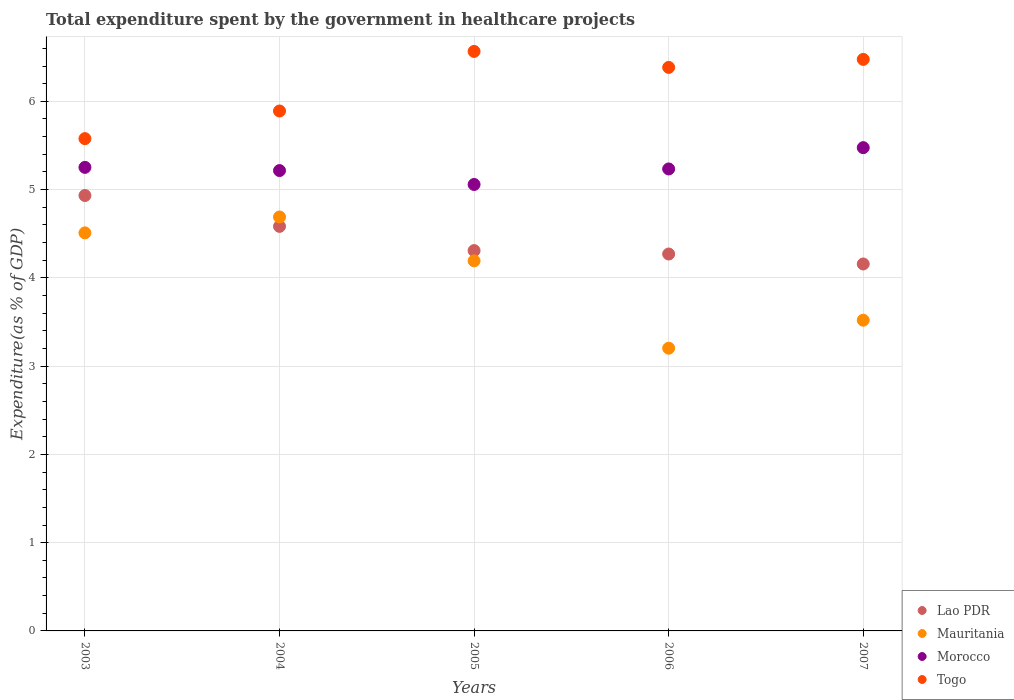Is the number of dotlines equal to the number of legend labels?
Keep it short and to the point. Yes. What is the total expenditure spent by the government in healthcare projects in Togo in 2005?
Offer a very short reply. 6.57. Across all years, what is the maximum total expenditure spent by the government in healthcare projects in Lao PDR?
Your answer should be compact. 4.93. Across all years, what is the minimum total expenditure spent by the government in healthcare projects in Morocco?
Ensure brevity in your answer.  5.06. In which year was the total expenditure spent by the government in healthcare projects in Lao PDR maximum?
Provide a succinct answer. 2003. What is the total total expenditure spent by the government in healthcare projects in Morocco in the graph?
Your answer should be compact. 26.23. What is the difference between the total expenditure spent by the government in healthcare projects in Togo in 2005 and that in 2006?
Ensure brevity in your answer.  0.18. What is the difference between the total expenditure spent by the government in healthcare projects in Morocco in 2003 and the total expenditure spent by the government in healthcare projects in Mauritania in 2005?
Ensure brevity in your answer.  1.06. What is the average total expenditure spent by the government in healthcare projects in Lao PDR per year?
Offer a very short reply. 4.45. In the year 2005, what is the difference between the total expenditure spent by the government in healthcare projects in Morocco and total expenditure spent by the government in healthcare projects in Lao PDR?
Provide a short and direct response. 0.75. What is the ratio of the total expenditure spent by the government in healthcare projects in Mauritania in 2003 to that in 2004?
Your answer should be compact. 0.96. Is the total expenditure spent by the government in healthcare projects in Morocco in 2004 less than that in 2006?
Your response must be concise. Yes. What is the difference between the highest and the second highest total expenditure spent by the government in healthcare projects in Mauritania?
Offer a very short reply. 0.18. What is the difference between the highest and the lowest total expenditure spent by the government in healthcare projects in Togo?
Ensure brevity in your answer.  0.99. Does the total expenditure spent by the government in healthcare projects in Togo monotonically increase over the years?
Offer a terse response. No. Is the total expenditure spent by the government in healthcare projects in Togo strictly less than the total expenditure spent by the government in healthcare projects in Mauritania over the years?
Give a very brief answer. No. How many years are there in the graph?
Your response must be concise. 5. What is the difference between two consecutive major ticks on the Y-axis?
Provide a succinct answer. 1. Are the values on the major ticks of Y-axis written in scientific E-notation?
Your answer should be very brief. No. Does the graph contain any zero values?
Your answer should be compact. No. Does the graph contain grids?
Your answer should be compact. Yes. How many legend labels are there?
Keep it short and to the point. 4. How are the legend labels stacked?
Provide a succinct answer. Vertical. What is the title of the graph?
Provide a short and direct response. Total expenditure spent by the government in healthcare projects. What is the label or title of the Y-axis?
Offer a very short reply. Expenditure(as % of GDP). What is the Expenditure(as % of GDP) of Lao PDR in 2003?
Ensure brevity in your answer.  4.93. What is the Expenditure(as % of GDP) of Mauritania in 2003?
Provide a succinct answer. 4.51. What is the Expenditure(as % of GDP) of Morocco in 2003?
Ensure brevity in your answer.  5.25. What is the Expenditure(as % of GDP) in Togo in 2003?
Make the answer very short. 5.58. What is the Expenditure(as % of GDP) of Lao PDR in 2004?
Provide a succinct answer. 4.58. What is the Expenditure(as % of GDP) of Mauritania in 2004?
Provide a short and direct response. 4.69. What is the Expenditure(as % of GDP) in Morocco in 2004?
Give a very brief answer. 5.22. What is the Expenditure(as % of GDP) in Togo in 2004?
Ensure brevity in your answer.  5.89. What is the Expenditure(as % of GDP) of Lao PDR in 2005?
Ensure brevity in your answer.  4.31. What is the Expenditure(as % of GDP) in Mauritania in 2005?
Your answer should be compact. 4.19. What is the Expenditure(as % of GDP) of Morocco in 2005?
Give a very brief answer. 5.06. What is the Expenditure(as % of GDP) in Togo in 2005?
Give a very brief answer. 6.57. What is the Expenditure(as % of GDP) of Lao PDR in 2006?
Provide a short and direct response. 4.27. What is the Expenditure(as % of GDP) of Mauritania in 2006?
Your answer should be compact. 3.2. What is the Expenditure(as % of GDP) of Morocco in 2006?
Provide a succinct answer. 5.23. What is the Expenditure(as % of GDP) of Togo in 2006?
Make the answer very short. 6.38. What is the Expenditure(as % of GDP) in Lao PDR in 2007?
Offer a very short reply. 4.16. What is the Expenditure(as % of GDP) of Mauritania in 2007?
Your response must be concise. 3.52. What is the Expenditure(as % of GDP) of Morocco in 2007?
Keep it short and to the point. 5.48. What is the Expenditure(as % of GDP) of Togo in 2007?
Provide a succinct answer. 6.48. Across all years, what is the maximum Expenditure(as % of GDP) of Lao PDR?
Your answer should be compact. 4.93. Across all years, what is the maximum Expenditure(as % of GDP) in Mauritania?
Your answer should be compact. 4.69. Across all years, what is the maximum Expenditure(as % of GDP) in Morocco?
Provide a short and direct response. 5.48. Across all years, what is the maximum Expenditure(as % of GDP) in Togo?
Provide a succinct answer. 6.57. Across all years, what is the minimum Expenditure(as % of GDP) of Lao PDR?
Provide a succinct answer. 4.16. Across all years, what is the minimum Expenditure(as % of GDP) of Mauritania?
Your answer should be very brief. 3.2. Across all years, what is the minimum Expenditure(as % of GDP) in Morocco?
Offer a terse response. 5.06. Across all years, what is the minimum Expenditure(as % of GDP) of Togo?
Offer a terse response. 5.58. What is the total Expenditure(as % of GDP) of Lao PDR in the graph?
Make the answer very short. 22.25. What is the total Expenditure(as % of GDP) in Mauritania in the graph?
Your response must be concise. 20.12. What is the total Expenditure(as % of GDP) in Morocco in the graph?
Offer a very short reply. 26.23. What is the total Expenditure(as % of GDP) of Togo in the graph?
Offer a very short reply. 30.89. What is the difference between the Expenditure(as % of GDP) of Lao PDR in 2003 and that in 2004?
Offer a terse response. 0.35. What is the difference between the Expenditure(as % of GDP) in Mauritania in 2003 and that in 2004?
Your answer should be compact. -0.18. What is the difference between the Expenditure(as % of GDP) in Morocco in 2003 and that in 2004?
Keep it short and to the point. 0.04. What is the difference between the Expenditure(as % of GDP) of Togo in 2003 and that in 2004?
Provide a succinct answer. -0.31. What is the difference between the Expenditure(as % of GDP) in Lao PDR in 2003 and that in 2005?
Provide a short and direct response. 0.62. What is the difference between the Expenditure(as % of GDP) of Mauritania in 2003 and that in 2005?
Make the answer very short. 0.32. What is the difference between the Expenditure(as % of GDP) of Morocco in 2003 and that in 2005?
Your answer should be very brief. 0.19. What is the difference between the Expenditure(as % of GDP) in Togo in 2003 and that in 2005?
Offer a terse response. -0.99. What is the difference between the Expenditure(as % of GDP) of Lao PDR in 2003 and that in 2006?
Offer a very short reply. 0.66. What is the difference between the Expenditure(as % of GDP) of Mauritania in 2003 and that in 2006?
Give a very brief answer. 1.31. What is the difference between the Expenditure(as % of GDP) of Morocco in 2003 and that in 2006?
Provide a short and direct response. 0.02. What is the difference between the Expenditure(as % of GDP) in Togo in 2003 and that in 2006?
Offer a very short reply. -0.81. What is the difference between the Expenditure(as % of GDP) of Lao PDR in 2003 and that in 2007?
Your answer should be compact. 0.78. What is the difference between the Expenditure(as % of GDP) of Mauritania in 2003 and that in 2007?
Your answer should be very brief. 0.99. What is the difference between the Expenditure(as % of GDP) in Morocco in 2003 and that in 2007?
Offer a terse response. -0.22. What is the difference between the Expenditure(as % of GDP) of Togo in 2003 and that in 2007?
Make the answer very short. -0.9. What is the difference between the Expenditure(as % of GDP) of Lao PDR in 2004 and that in 2005?
Provide a succinct answer. 0.27. What is the difference between the Expenditure(as % of GDP) in Mauritania in 2004 and that in 2005?
Offer a very short reply. 0.5. What is the difference between the Expenditure(as % of GDP) in Morocco in 2004 and that in 2005?
Ensure brevity in your answer.  0.16. What is the difference between the Expenditure(as % of GDP) of Togo in 2004 and that in 2005?
Offer a terse response. -0.68. What is the difference between the Expenditure(as % of GDP) in Lao PDR in 2004 and that in 2006?
Ensure brevity in your answer.  0.31. What is the difference between the Expenditure(as % of GDP) of Mauritania in 2004 and that in 2006?
Ensure brevity in your answer.  1.49. What is the difference between the Expenditure(as % of GDP) of Morocco in 2004 and that in 2006?
Make the answer very short. -0.02. What is the difference between the Expenditure(as % of GDP) in Togo in 2004 and that in 2006?
Give a very brief answer. -0.49. What is the difference between the Expenditure(as % of GDP) in Lao PDR in 2004 and that in 2007?
Your answer should be compact. 0.43. What is the difference between the Expenditure(as % of GDP) of Mauritania in 2004 and that in 2007?
Your response must be concise. 1.17. What is the difference between the Expenditure(as % of GDP) of Morocco in 2004 and that in 2007?
Provide a short and direct response. -0.26. What is the difference between the Expenditure(as % of GDP) of Togo in 2004 and that in 2007?
Keep it short and to the point. -0.58. What is the difference between the Expenditure(as % of GDP) in Lao PDR in 2005 and that in 2006?
Your answer should be very brief. 0.04. What is the difference between the Expenditure(as % of GDP) of Mauritania in 2005 and that in 2006?
Keep it short and to the point. 0.99. What is the difference between the Expenditure(as % of GDP) of Morocco in 2005 and that in 2006?
Your answer should be very brief. -0.18. What is the difference between the Expenditure(as % of GDP) in Togo in 2005 and that in 2006?
Make the answer very short. 0.18. What is the difference between the Expenditure(as % of GDP) in Lao PDR in 2005 and that in 2007?
Give a very brief answer. 0.15. What is the difference between the Expenditure(as % of GDP) in Mauritania in 2005 and that in 2007?
Your response must be concise. 0.67. What is the difference between the Expenditure(as % of GDP) in Morocco in 2005 and that in 2007?
Offer a very short reply. -0.42. What is the difference between the Expenditure(as % of GDP) in Togo in 2005 and that in 2007?
Provide a short and direct response. 0.09. What is the difference between the Expenditure(as % of GDP) in Lao PDR in 2006 and that in 2007?
Your answer should be compact. 0.11. What is the difference between the Expenditure(as % of GDP) of Mauritania in 2006 and that in 2007?
Keep it short and to the point. -0.32. What is the difference between the Expenditure(as % of GDP) in Morocco in 2006 and that in 2007?
Offer a very short reply. -0.24. What is the difference between the Expenditure(as % of GDP) of Togo in 2006 and that in 2007?
Provide a succinct answer. -0.09. What is the difference between the Expenditure(as % of GDP) of Lao PDR in 2003 and the Expenditure(as % of GDP) of Mauritania in 2004?
Offer a terse response. 0.24. What is the difference between the Expenditure(as % of GDP) in Lao PDR in 2003 and the Expenditure(as % of GDP) in Morocco in 2004?
Ensure brevity in your answer.  -0.28. What is the difference between the Expenditure(as % of GDP) in Lao PDR in 2003 and the Expenditure(as % of GDP) in Togo in 2004?
Offer a very short reply. -0.96. What is the difference between the Expenditure(as % of GDP) in Mauritania in 2003 and the Expenditure(as % of GDP) in Morocco in 2004?
Offer a very short reply. -0.71. What is the difference between the Expenditure(as % of GDP) in Mauritania in 2003 and the Expenditure(as % of GDP) in Togo in 2004?
Offer a very short reply. -1.38. What is the difference between the Expenditure(as % of GDP) of Morocco in 2003 and the Expenditure(as % of GDP) of Togo in 2004?
Ensure brevity in your answer.  -0.64. What is the difference between the Expenditure(as % of GDP) of Lao PDR in 2003 and the Expenditure(as % of GDP) of Mauritania in 2005?
Offer a terse response. 0.74. What is the difference between the Expenditure(as % of GDP) in Lao PDR in 2003 and the Expenditure(as % of GDP) in Morocco in 2005?
Offer a terse response. -0.12. What is the difference between the Expenditure(as % of GDP) in Lao PDR in 2003 and the Expenditure(as % of GDP) in Togo in 2005?
Give a very brief answer. -1.63. What is the difference between the Expenditure(as % of GDP) of Mauritania in 2003 and the Expenditure(as % of GDP) of Morocco in 2005?
Give a very brief answer. -0.55. What is the difference between the Expenditure(as % of GDP) in Mauritania in 2003 and the Expenditure(as % of GDP) in Togo in 2005?
Your answer should be very brief. -2.06. What is the difference between the Expenditure(as % of GDP) in Morocco in 2003 and the Expenditure(as % of GDP) in Togo in 2005?
Provide a succinct answer. -1.31. What is the difference between the Expenditure(as % of GDP) of Lao PDR in 2003 and the Expenditure(as % of GDP) of Mauritania in 2006?
Your answer should be compact. 1.73. What is the difference between the Expenditure(as % of GDP) in Lao PDR in 2003 and the Expenditure(as % of GDP) in Morocco in 2006?
Provide a short and direct response. -0.3. What is the difference between the Expenditure(as % of GDP) of Lao PDR in 2003 and the Expenditure(as % of GDP) of Togo in 2006?
Ensure brevity in your answer.  -1.45. What is the difference between the Expenditure(as % of GDP) in Mauritania in 2003 and the Expenditure(as % of GDP) in Morocco in 2006?
Your response must be concise. -0.72. What is the difference between the Expenditure(as % of GDP) in Mauritania in 2003 and the Expenditure(as % of GDP) in Togo in 2006?
Your response must be concise. -1.87. What is the difference between the Expenditure(as % of GDP) in Morocco in 2003 and the Expenditure(as % of GDP) in Togo in 2006?
Keep it short and to the point. -1.13. What is the difference between the Expenditure(as % of GDP) in Lao PDR in 2003 and the Expenditure(as % of GDP) in Mauritania in 2007?
Give a very brief answer. 1.41. What is the difference between the Expenditure(as % of GDP) of Lao PDR in 2003 and the Expenditure(as % of GDP) of Morocco in 2007?
Offer a very short reply. -0.54. What is the difference between the Expenditure(as % of GDP) of Lao PDR in 2003 and the Expenditure(as % of GDP) of Togo in 2007?
Provide a short and direct response. -1.54. What is the difference between the Expenditure(as % of GDP) in Mauritania in 2003 and the Expenditure(as % of GDP) in Morocco in 2007?
Your response must be concise. -0.97. What is the difference between the Expenditure(as % of GDP) in Mauritania in 2003 and the Expenditure(as % of GDP) in Togo in 2007?
Your answer should be very brief. -1.97. What is the difference between the Expenditure(as % of GDP) in Morocco in 2003 and the Expenditure(as % of GDP) in Togo in 2007?
Provide a succinct answer. -1.22. What is the difference between the Expenditure(as % of GDP) of Lao PDR in 2004 and the Expenditure(as % of GDP) of Mauritania in 2005?
Offer a terse response. 0.39. What is the difference between the Expenditure(as % of GDP) of Lao PDR in 2004 and the Expenditure(as % of GDP) of Morocco in 2005?
Offer a very short reply. -0.47. What is the difference between the Expenditure(as % of GDP) of Lao PDR in 2004 and the Expenditure(as % of GDP) of Togo in 2005?
Your answer should be very brief. -1.98. What is the difference between the Expenditure(as % of GDP) of Mauritania in 2004 and the Expenditure(as % of GDP) of Morocco in 2005?
Make the answer very short. -0.37. What is the difference between the Expenditure(as % of GDP) of Mauritania in 2004 and the Expenditure(as % of GDP) of Togo in 2005?
Keep it short and to the point. -1.88. What is the difference between the Expenditure(as % of GDP) in Morocco in 2004 and the Expenditure(as % of GDP) in Togo in 2005?
Offer a very short reply. -1.35. What is the difference between the Expenditure(as % of GDP) of Lao PDR in 2004 and the Expenditure(as % of GDP) of Mauritania in 2006?
Offer a terse response. 1.38. What is the difference between the Expenditure(as % of GDP) in Lao PDR in 2004 and the Expenditure(as % of GDP) in Morocco in 2006?
Offer a terse response. -0.65. What is the difference between the Expenditure(as % of GDP) in Lao PDR in 2004 and the Expenditure(as % of GDP) in Togo in 2006?
Ensure brevity in your answer.  -1.8. What is the difference between the Expenditure(as % of GDP) of Mauritania in 2004 and the Expenditure(as % of GDP) of Morocco in 2006?
Your response must be concise. -0.54. What is the difference between the Expenditure(as % of GDP) of Mauritania in 2004 and the Expenditure(as % of GDP) of Togo in 2006?
Give a very brief answer. -1.69. What is the difference between the Expenditure(as % of GDP) of Morocco in 2004 and the Expenditure(as % of GDP) of Togo in 2006?
Offer a very short reply. -1.17. What is the difference between the Expenditure(as % of GDP) of Lao PDR in 2004 and the Expenditure(as % of GDP) of Mauritania in 2007?
Offer a terse response. 1.06. What is the difference between the Expenditure(as % of GDP) in Lao PDR in 2004 and the Expenditure(as % of GDP) in Morocco in 2007?
Provide a succinct answer. -0.89. What is the difference between the Expenditure(as % of GDP) in Lao PDR in 2004 and the Expenditure(as % of GDP) in Togo in 2007?
Your response must be concise. -1.89. What is the difference between the Expenditure(as % of GDP) of Mauritania in 2004 and the Expenditure(as % of GDP) of Morocco in 2007?
Provide a short and direct response. -0.79. What is the difference between the Expenditure(as % of GDP) of Mauritania in 2004 and the Expenditure(as % of GDP) of Togo in 2007?
Make the answer very short. -1.79. What is the difference between the Expenditure(as % of GDP) of Morocco in 2004 and the Expenditure(as % of GDP) of Togo in 2007?
Your answer should be compact. -1.26. What is the difference between the Expenditure(as % of GDP) in Lao PDR in 2005 and the Expenditure(as % of GDP) in Mauritania in 2006?
Your answer should be very brief. 1.11. What is the difference between the Expenditure(as % of GDP) in Lao PDR in 2005 and the Expenditure(as % of GDP) in Morocco in 2006?
Provide a succinct answer. -0.93. What is the difference between the Expenditure(as % of GDP) in Lao PDR in 2005 and the Expenditure(as % of GDP) in Togo in 2006?
Your answer should be very brief. -2.08. What is the difference between the Expenditure(as % of GDP) in Mauritania in 2005 and the Expenditure(as % of GDP) in Morocco in 2006?
Provide a short and direct response. -1.04. What is the difference between the Expenditure(as % of GDP) in Mauritania in 2005 and the Expenditure(as % of GDP) in Togo in 2006?
Offer a very short reply. -2.19. What is the difference between the Expenditure(as % of GDP) in Morocco in 2005 and the Expenditure(as % of GDP) in Togo in 2006?
Provide a short and direct response. -1.33. What is the difference between the Expenditure(as % of GDP) of Lao PDR in 2005 and the Expenditure(as % of GDP) of Mauritania in 2007?
Your answer should be very brief. 0.79. What is the difference between the Expenditure(as % of GDP) of Lao PDR in 2005 and the Expenditure(as % of GDP) of Morocco in 2007?
Ensure brevity in your answer.  -1.17. What is the difference between the Expenditure(as % of GDP) of Lao PDR in 2005 and the Expenditure(as % of GDP) of Togo in 2007?
Provide a short and direct response. -2.17. What is the difference between the Expenditure(as % of GDP) of Mauritania in 2005 and the Expenditure(as % of GDP) of Morocco in 2007?
Offer a very short reply. -1.28. What is the difference between the Expenditure(as % of GDP) of Mauritania in 2005 and the Expenditure(as % of GDP) of Togo in 2007?
Offer a terse response. -2.28. What is the difference between the Expenditure(as % of GDP) of Morocco in 2005 and the Expenditure(as % of GDP) of Togo in 2007?
Offer a very short reply. -1.42. What is the difference between the Expenditure(as % of GDP) of Lao PDR in 2006 and the Expenditure(as % of GDP) of Mauritania in 2007?
Your answer should be very brief. 0.75. What is the difference between the Expenditure(as % of GDP) in Lao PDR in 2006 and the Expenditure(as % of GDP) in Morocco in 2007?
Your answer should be compact. -1.21. What is the difference between the Expenditure(as % of GDP) of Lao PDR in 2006 and the Expenditure(as % of GDP) of Togo in 2007?
Offer a very short reply. -2.2. What is the difference between the Expenditure(as % of GDP) in Mauritania in 2006 and the Expenditure(as % of GDP) in Morocco in 2007?
Provide a short and direct response. -2.27. What is the difference between the Expenditure(as % of GDP) in Mauritania in 2006 and the Expenditure(as % of GDP) in Togo in 2007?
Your response must be concise. -3.27. What is the difference between the Expenditure(as % of GDP) in Morocco in 2006 and the Expenditure(as % of GDP) in Togo in 2007?
Provide a succinct answer. -1.24. What is the average Expenditure(as % of GDP) of Lao PDR per year?
Ensure brevity in your answer.  4.45. What is the average Expenditure(as % of GDP) in Mauritania per year?
Provide a short and direct response. 4.02. What is the average Expenditure(as % of GDP) of Morocco per year?
Ensure brevity in your answer.  5.25. What is the average Expenditure(as % of GDP) in Togo per year?
Offer a terse response. 6.18. In the year 2003, what is the difference between the Expenditure(as % of GDP) in Lao PDR and Expenditure(as % of GDP) in Mauritania?
Your answer should be compact. 0.42. In the year 2003, what is the difference between the Expenditure(as % of GDP) of Lao PDR and Expenditure(as % of GDP) of Morocco?
Offer a very short reply. -0.32. In the year 2003, what is the difference between the Expenditure(as % of GDP) in Lao PDR and Expenditure(as % of GDP) in Togo?
Provide a succinct answer. -0.64. In the year 2003, what is the difference between the Expenditure(as % of GDP) in Mauritania and Expenditure(as % of GDP) in Morocco?
Keep it short and to the point. -0.74. In the year 2003, what is the difference between the Expenditure(as % of GDP) of Mauritania and Expenditure(as % of GDP) of Togo?
Make the answer very short. -1.07. In the year 2003, what is the difference between the Expenditure(as % of GDP) in Morocco and Expenditure(as % of GDP) in Togo?
Offer a terse response. -0.33. In the year 2004, what is the difference between the Expenditure(as % of GDP) of Lao PDR and Expenditure(as % of GDP) of Mauritania?
Provide a short and direct response. -0.11. In the year 2004, what is the difference between the Expenditure(as % of GDP) of Lao PDR and Expenditure(as % of GDP) of Morocco?
Give a very brief answer. -0.63. In the year 2004, what is the difference between the Expenditure(as % of GDP) of Lao PDR and Expenditure(as % of GDP) of Togo?
Ensure brevity in your answer.  -1.31. In the year 2004, what is the difference between the Expenditure(as % of GDP) of Mauritania and Expenditure(as % of GDP) of Morocco?
Offer a terse response. -0.53. In the year 2004, what is the difference between the Expenditure(as % of GDP) in Mauritania and Expenditure(as % of GDP) in Togo?
Make the answer very short. -1.2. In the year 2004, what is the difference between the Expenditure(as % of GDP) in Morocco and Expenditure(as % of GDP) in Togo?
Offer a terse response. -0.68. In the year 2005, what is the difference between the Expenditure(as % of GDP) in Lao PDR and Expenditure(as % of GDP) in Mauritania?
Offer a terse response. 0.12. In the year 2005, what is the difference between the Expenditure(as % of GDP) of Lao PDR and Expenditure(as % of GDP) of Morocco?
Give a very brief answer. -0.75. In the year 2005, what is the difference between the Expenditure(as % of GDP) in Lao PDR and Expenditure(as % of GDP) in Togo?
Your response must be concise. -2.26. In the year 2005, what is the difference between the Expenditure(as % of GDP) in Mauritania and Expenditure(as % of GDP) in Morocco?
Your answer should be very brief. -0.87. In the year 2005, what is the difference between the Expenditure(as % of GDP) in Mauritania and Expenditure(as % of GDP) in Togo?
Your answer should be compact. -2.37. In the year 2005, what is the difference between the Expenditure(as % of GDP) in Morocco and Expenditure(as % of GDP) in Togo?
Provide a short and direct response. -1.51. In the year 2006, what is the difference between the Expenditure(as % of GDP) of Lao PDR and Expenditure(as % of GDP) of Mauritania?
Keep it short and to the point. 1.07. In the year 2006, what is the difference between the Expenditure(as % of GDP) of Lao PDR and Expenditure(as % of GDP) of Morocco?
Keep it short and to the point. -0.96. In the year 2006, what is the difference between the Expenditure(as % of GDP) in Lao PDR and Expenditure(as % of GDP) in Togo?
Keep it short and to the point. -2.11. In the year 2006, what is the difference between the Expenditure(as % of GDP) of Mauritania and Expenditure(as % of GDP) of Morocco?
Provide a short and direct response. -2.03. In the year 2006, what is the difference between the Expenditure(as % of GDP) in Mauritania and Expenditure(as % of GDP) in Togo?
Offer a very short reply. -3.18. In the year 2006, what is the difference between the Expenditure(as % of GDP) of Morocco and Expenditure(as % of GDP) of Togo?
Give a very brief answer. -1.15. In the year 2007, what is the difference between the Expenditure(as % of GDP) of Lao PDR and Expenditure(as % of GDP) of Mauritania?
Provide a short and direct response. 0.64. In the year 2007, what is the difference between the Expenditure(as % of GDP) of Lao PDR and Expenditure(as % of GDP) of Morocco?
Make the answer very short. -1.32. In the year 2007, what is the difference between the Expenditure(as % of GDP) in Lao PDR and Expenditure(as % of GDP) in Togo?
Offer a terse response. -2.32. In the year 2007, what is the difference between the Expenditure(as % of GDP) in Mauritania and Expenditure(as % of GDP) in Morocco?
Offer a very short reply. -1.95. In the year 2007, what is the difference between the Expenditure(as % of GDP) of Mauritania and Expenditure(as % of GDP) of Togo?
Keep it short and to the point. -2.95. In the year 2007, what is the difference between the Expenditure(as % of GDP) of Morocco and Expenditure(as % of GDP) of Togo?
Offer a terse response. -1. What is the ratio of the Expenditure(as % of GDP) of Lao PDR in 2003 to that in 2004?
Offer a terse response. 1.08. What is the ratio of the Expenditure(as % of GDP) of Mauritania in 2003 to that in 2004?
Provide a succinct answer. 0.96. What is the ratio of the Expenditure(as % of GDP) in Morocco in 2003 to that in 2004?
Offer a terse response. 1.01. What is the ratio of the Expenditure(as % of GDP) in Togo in 2003 to that in 2004?
Provide a succinct answer. 0.95. What is the ratio of the Expenditure(as % of GDP) in Lao PDR in 2003 to that in 2005?
Your response must be concise. 1.14. What is the ratio of the Expenditure(as % of GDP) of Mauritania in 2003 to that in 2005?
Offer a very short reply. 1.08. What is the ratio of the Expenditure(as % of GDP) in Morocco in 2003 to that in 2005?
Your answer should be very brief. 1.04. What is the ratio of the Expenditure(as % of GDP) of Togo in 2003 to that in 2005?
Provide a succinct answer. 0.85. What is the ratio of the Expenditure(as % of GDP) of Lao PDR in 2003 to that in 2006?
Make the answer very short. 1.16. What is the ratio of the Expenditure(as % of GDP) in Mauritania in 2003 to that in 2006?
Offer a very short reply. 1.41. What is the ratio of the Expenditure(as % of GDP) in Morocco in 2003 to that in 2006?
Offer a terse response. 1. What is the ratio of the Expenditure(as % of GDP) of Togo in 2003 to that in 2006?
Make the answer very short. 0.87. What is the ratio of the Expenditure(as % of GDP) in Lao PDR in 2003 to that in 2007?
Your answer should be compact. 1.19. What is the ratio of the Expenditure(as % of GDP) in Mauritania in 2003 to that in 2007?
Make the answer very short. 1.28. What is the ratio of the Expenditure(as % of GDP) in Morocco in 2003 to that in 2007?
Your answer should be compact. 0.96. What is the ratio of the Expenditure(as % of GDP) in Togo in 2003 to that in 2007?
Your response must be concise. 0.86. What is the ratio of the Expenditure(as % of GDP) in Lao PDR in 2004 to that in 2005?
Provide a short and direct response. 1.06. What is the ratio of the Expenditure(as % of GDP) of Mauritania in 2004 to that in 2005?
Your response must be concise. 1.12. What is the ratio of the Expenditure(as % of GDP) in Morocco in 2004 to that in 2005?
Ensure brevity in your answer.  1.03. What is the ratio of the Expenditure(as % of GDP) of Togo in 2004 to that in 2005?
Your response must be concise. 0.9. What is the ratio of the Expenditure(as % of GDP) of Lao PDR in 2004 to that in 2006?
Ensure brevity in your answer.  1.07. What is the ratio of the Expenditure(as % of GDP) of Mauritania in 2004 to that in 2006?
Your response must be concise. 1.46. What is the ratio of the Expenditure(as % of GDP) of Morocco in 2004 to that in 2006?
Your response must be concise. 1. What is the ratio of the Expenditure(as % of GDP) in Togo in 2004 to that in 2006?
Ensure brevity in your answer.  0.92. What is the ratio of the Expenditure(as % of GDP) in Lao PDR in 2004 to that in 2007?
Offer a terse response. 1.1. What is the ratio of the Expenditure(as % of GDP) in Mauritania in 2004 to that in 2007?
Give a very brief answer. 1.33. What is the ratio of the Expenditure(as % of GDP) of Morocco in 2004 to that in 2007?
Give a very brief answer. 0.95. What is the ratio of the Expenditure(as % of GDP) of Togo in 2004 to that in 2007?
Offer a very short reply. 0.91. What is the ratio of the Expenditure(as % of GDP) of Lao PDR in 2005 to that in 2006?
Offer a very short reply. 1.01. What is the ratio of the Expenditure(as % of GDP) in Mauritania in 2005 to that in 2006?
Offer a terse response. 1.31. What is the ratio of the Expenditure(as % of GDP) in Morocco in 2005 to that in 2006?
Ensure brevity in your answer.  0.97. What is the ratio of the Expenditure(as % of GDP) in Togo in 2005 to that in 2006?
Keep it short and to the point. 1.03. What is the ratio of the Expenditure(as % of GDP) in Lao PDR in 2005 to that in 2007?
Make the answer very short. 1.04. What is the ratio of the Expenditure(as % of GDP) in Mauritania in 2005 to that in 2007?
Keep it short and to the point. 1.19. What is the ratio of the Expenditure(as % of GDP) of Morocco in 2005 to that in 2007?
Offer a very short reply. 0.92. What is the ratio of the Expenditure(as % of GDP) in Togo in 2005 to that in 2007?
Provide a short and direct response. 1.01. What is the ratio of the Expenditure(as % of GDP) in Lao PDR in 2006 to that in 2007?
Your response must be concise. 1.03. What is the ratio of the Expenditure(as % of GDP) in Mauritania in 2006 to that in 2007?
Offer a terse response. 0.91. What is the ratio of the Expenditure(as % of GDP) of Morocco in 2006 to that in 2007?
Provide a short and direct response. 0.96. What is the ratio of the Expenditure(as % of GDP) in Togo in 2006 to that in 2007?
Make the answer very short. 0.99. What is the difference between the highest and the second highest Expenditure(as % of GDP) of Lao PDR?
Your answer should be very brief. 0.35. What is the difference between the highest and the second highest Expenditure(as % of GDP) of Mauritania?
Offer a very short reply. 0.18. What is the difference between the highest and the second highest Expenditure(as % of GDP) of Morocco?
Your answer should be very brief. 0.22. What is the difference between the highest and the second highest Expenditure(as % of GDP) of Togo?
Your answer should be compact. 0.09. What is the difference between the highest and the lowest Expenditure(as % of GDP) of Lao PDR?
Give a very brief answer. 0.78. What is the difference between the highest and the lowest Expenditure(as % of GDP) of Mauritania?
Offer a very short reply. 1.49. What is the difference between the highest and the lowest Expenditure(as % of GDP) in Morocco?
Ensure brevity in your answer.  0.42. What is the difference between the highest and the lowest Expenditure(as % of GDP) in Togo?
Your response must be concise. 0.99. 